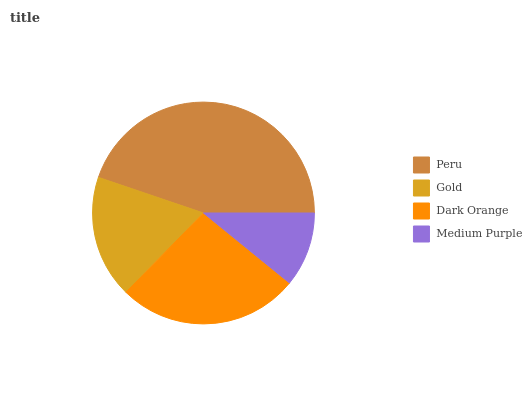Is Medium Purple the minimum?
Answer yes or no. Yes. Is Peru the maximum?
Answer yes or no. Yes. Is Gold the minimum?
Answer yes or no. No. Is Gold the maximum?
Answer yes or no. No. Is Peru greater than Gold?
Answer yes or no. Yes. Is Gold less than Peru?
Answer yes or no. Yes. Is Gold greater than Peru?
Answer yes or no. No. Is Peru less than Gold?
Answer yes or no. No. Is Dark Orange the high median?
Answer yes or no. Yes. Is Gold the low median?
Answer yes or no. Yes. Is Gold the high median?
Answer yes or no. No. Is Medium Purple the low median?
Answer yes or no. No. 